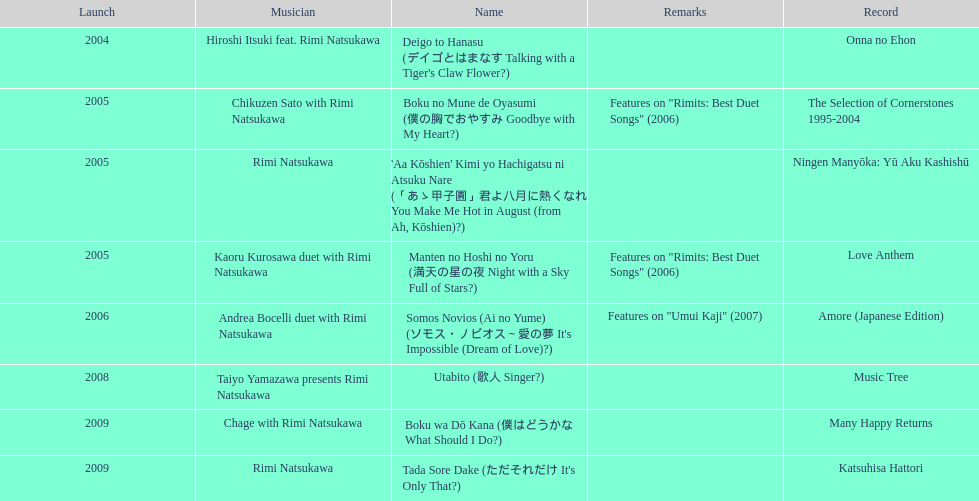How many titles have only one artist? 2. 